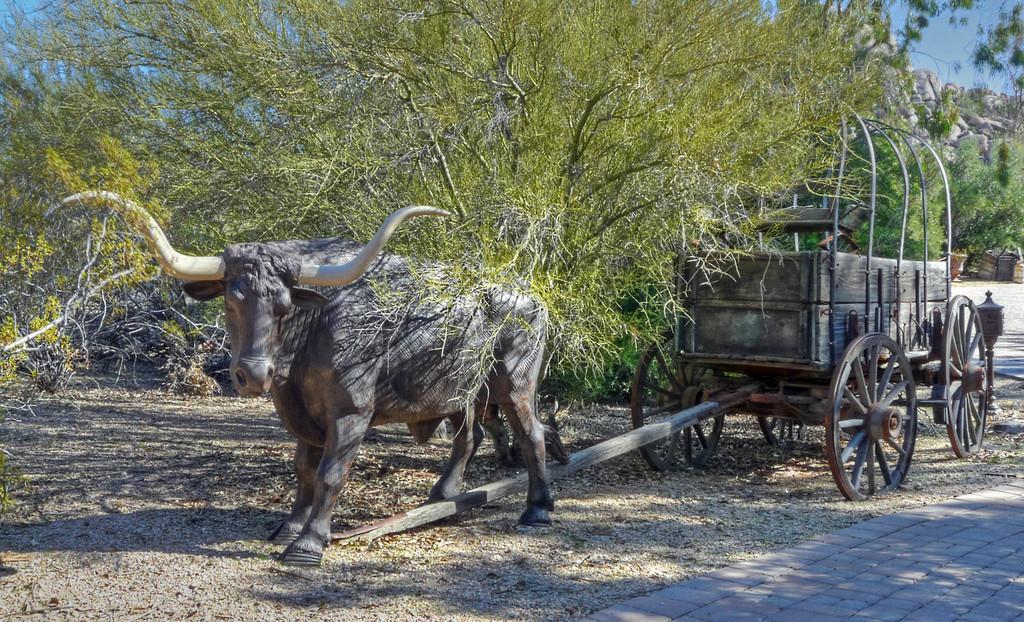Describe this image in one or two sentences. In this picture I can see sculpture of buffalo cart, side we can see some trees and rocks. 